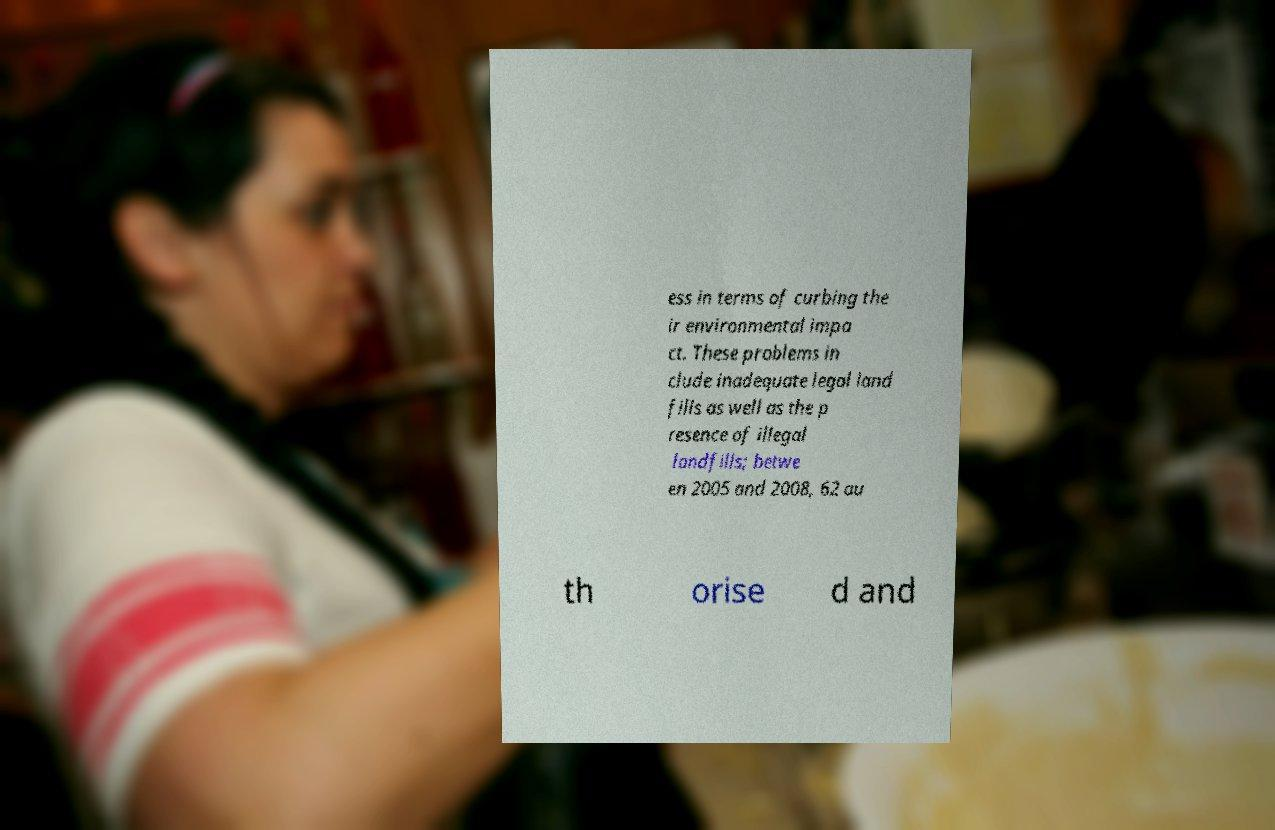Please identify and transcribe the text found in this image. ess in terms of curbing the ir environmental impa ct. These problems in clude inadequate legal land fills as well as the p resence of illegal landfills; betwe en 2005 and 2008, 62 au th orise d and 